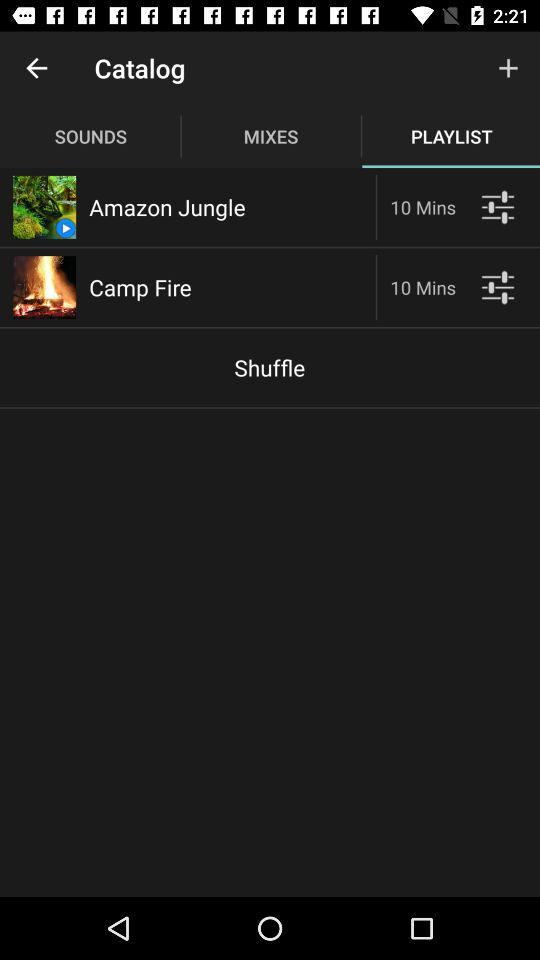Which tab is selected? The selected tab is "PLAYLIST". 